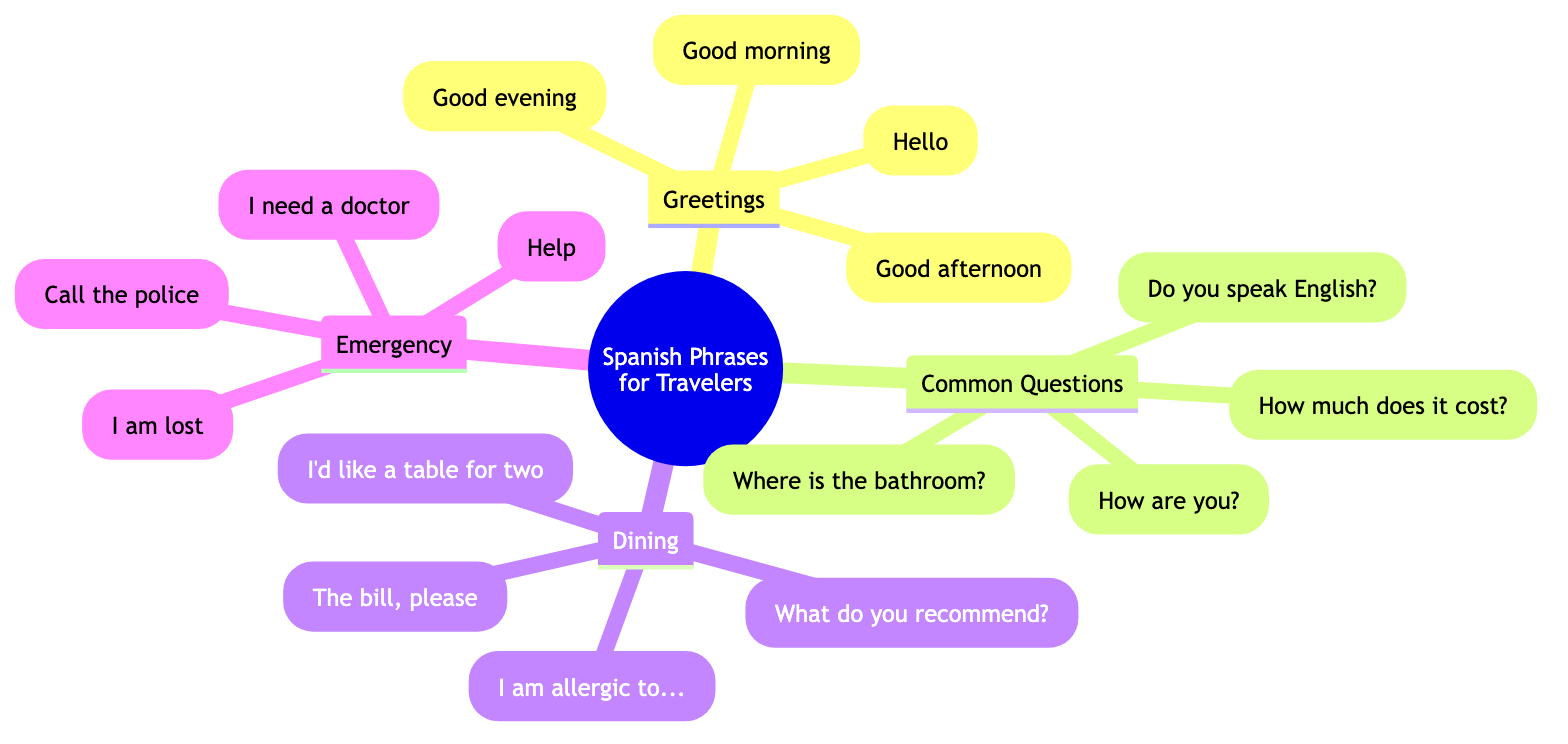What are the four categories of phrases listed? The diagram shows phrases organized into four main categories, which are labeled as "Greetings," "Common Questions," "Dining," and "Emergency." Each category contains specific phrases relevant to that theme.
Answer: Greetings, Common Questions, Dining, Emergency How many phrases are listed under "Dining"? Under the "Dining" category, there are four phrases provided, specifically: "La cuenta, por favor," "Quisiera una mesa para dos," "¿Qué recomienda?" and "Estoy alérgico a...". Counting these gives a total of four phrases.
Answer: 4 What is the Spanish phrase for "Help"? The diagram directly indicates that the Spanish phrase for "Help" is "Ayuda," which is categorized under "Emergency." This specific phrase is easily identifiable within the category.
Answer: Ayuda Which phrase is used to ask about someone’s well-being? The question "¿Cómo estás?" translates to "How are you?" in English, making it the phrase used to inquire about someone's well-being. This phrase is found under the "Common Questions" category.
Answer: ¿Cómo estás? What is the translation of "La cuenta, por favor"? The phrase "La cuenta, por favor" translates to "The bill, please" in English. This phrase is located within the "Dining" section of the diagram, making it clear where to find it.
Answer: The bill, please Which category has the phrase "¿Dónde está el baño?"? The phrase "¿Dónde está el baño?" is found under the "Common Questions" category. This is based on the organization of the phrases in the diagram, where it is explicitly listed.
Answer: Common Questions How many phrases are there in the "Emergency" category? The "Emergency" category includes four phrases: "Ayuda," "Llama a la policía," "Necesito un médico," and "Estoy perdido." Thus, by counting these phrases, we can confirm there are four.
Answer: 4 What is the phrase for "What do you recommend?" in Spanish? The Spanish phrase for "What do you recommend?" is "¿Qué recomienda?" This phrase can be found under the "Dining" category, which makes it straightforward to locate in the diagram.
Answer: ¿Qué recomienda? 